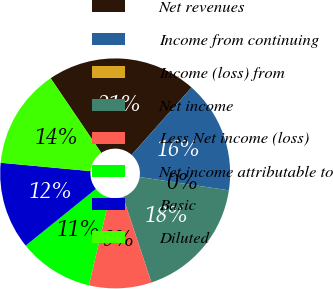Convert chart to OTSL. <chart><loc_0><loc_0><loc_500><loc_500><pie_chart><fcel>Net revenues<fcel>Income from continuing<fcel>Income (loss) from<fcel>Net income<fcel>Less Net income (loss)<fcel>Net income attributable to<fcel>Basic<fcel>Diluted<nl><fcel>21.05%<fcel>15.79%<fcel>0.0%<fcel>17.54%<fcel>8.77%<fcel>10.53%<fcel>12.28%<fcel>14.04%<nl></chart> 